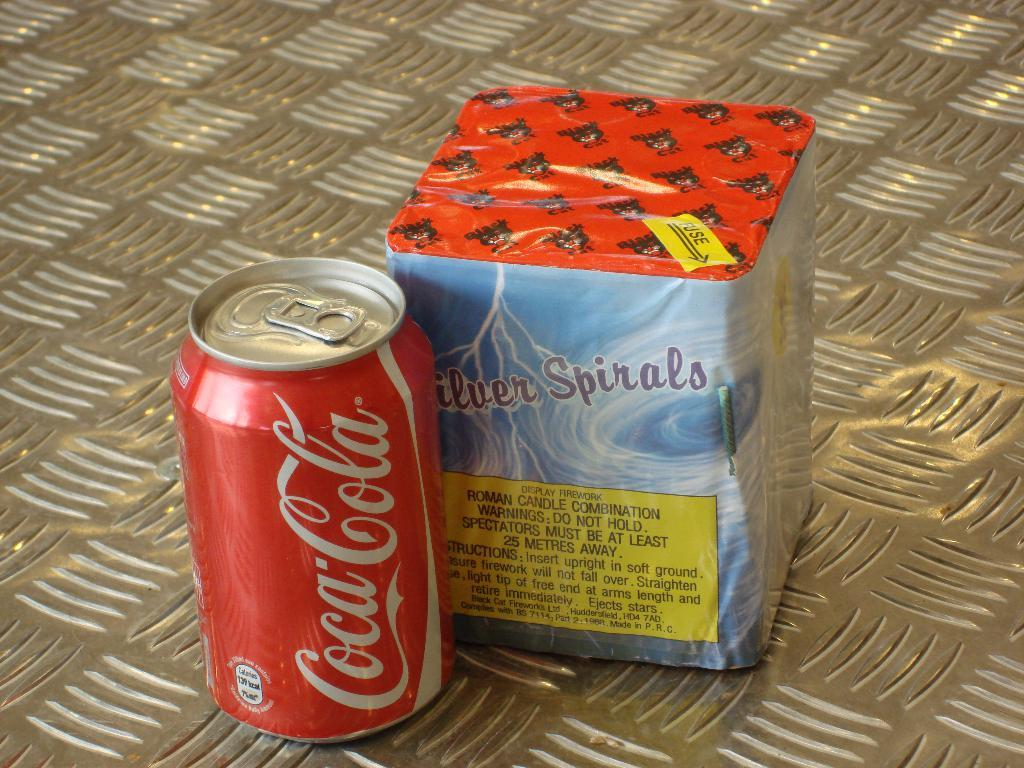<image>
Present a compact description of the photo's key features. a Coca Cola can unopened next to a Silver Spirals Roman Candle display firework in a box. 